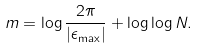Convert formula to latex. <formula><loc_0><loc_0><loc_500><loc_500>m = \log { \frac { 2 \pi } { | \epsilon _ { \max } | } } + \log \log { N } .</formula> 